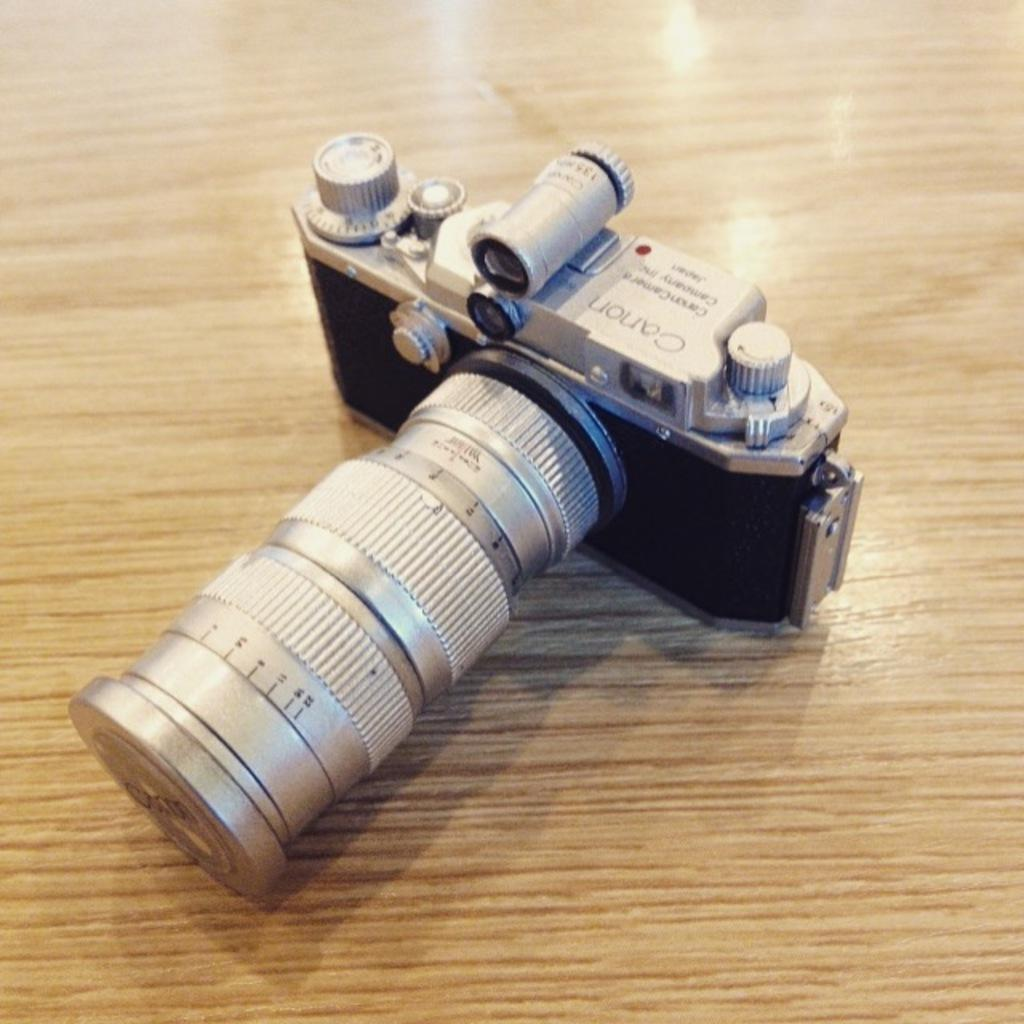What is the main object in the image? There is a camera in the image. Can you describe any additional details about the camera? Unfortunately, the provided facts do not offer any additional details about the camera. What else can be seen in the image besides the camera? There is text or writing visible in the image. How many legs does the camera have in the image? Cameras do not have legs; they are stationary objects. The image does not show any legs attached to the camera. 